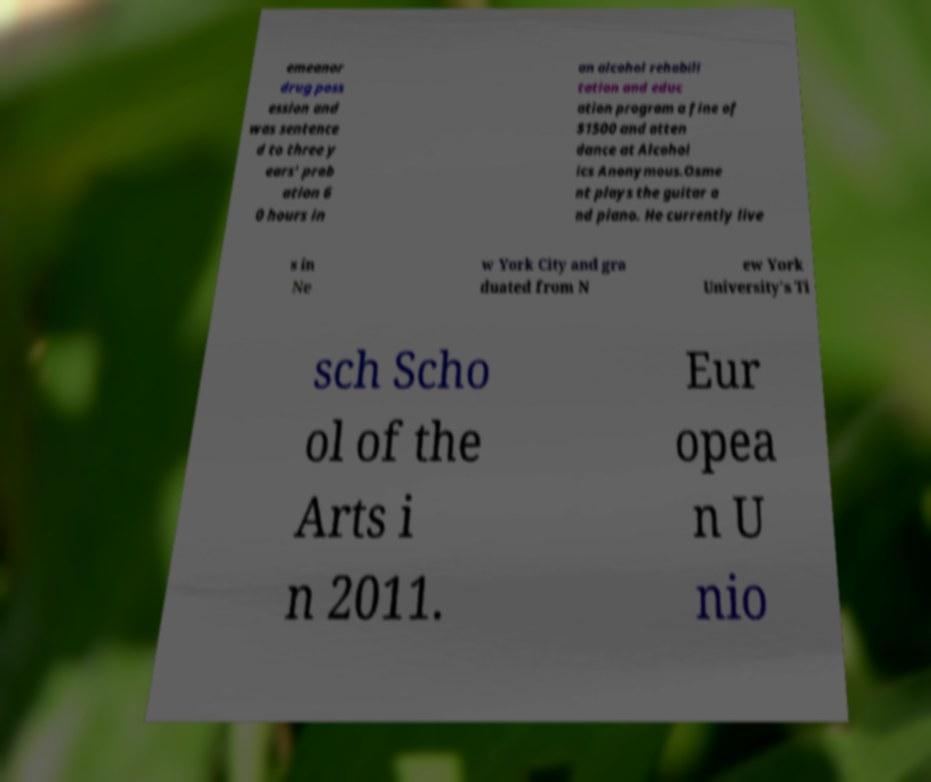What messages or text are displayed in this image? I need them in a readable, typed format. emeanor drug poss ession and was sentence d to three y ears' prob ation 6 0 hours in an alcohol rehabili tation and educ ation program a fine of $1500 and atten dance at Alcohol ics Anonymous.Osme nt plays the guitar a nd piano. He currently live s in Ne w York City and gra duated from N ew York University's Ti sch Scho ol of the Arts i n 2011. Eur opea n U nio 